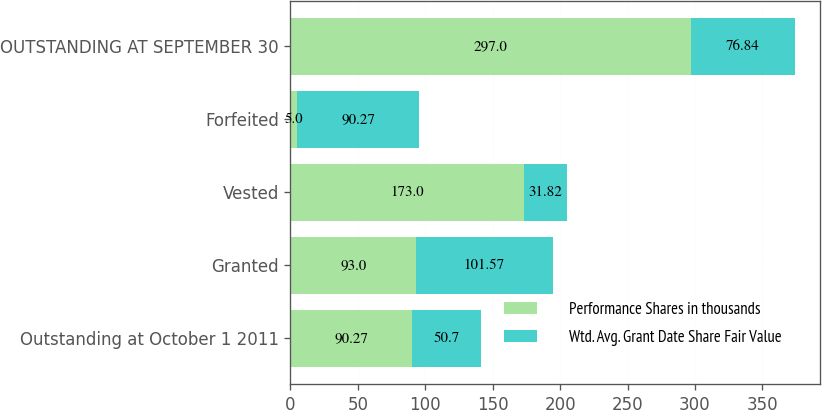Convert chart to OTSL. <chart><loc_0><loc_0><loc_500><loc_500><stacked_bar_chart><ecel><fcel>Outstanding at October 1 2011<fcel>Granted<fcel>Vested<fcel>Forfeited<fcel>OUTSTANDING AT SEPTEMBER 30<nl><fcel>Performance Shares in thousands<fcel>90.27<fcel>93<fcel>173<fcel>5<fcel>297<nl><fcel>Wtd. Avg. Grant Date Share Fair Value<fcel>50.7<fcel>101.57<fcel>31.82<fcel>90.27<fcel>76.84<nl></chart> 